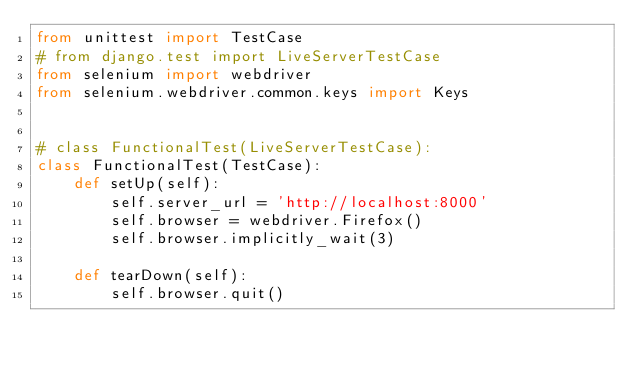Convert code to text. <code><loc_0><loc_0><loc_500><loc_500><_Python_>from unittest import TestCase
# from django.test import LiveServerTestCase
from selenium import webdriver
from selenium.webdriver.common.keys import Keys


# class FunctionalTest(LiveServerTestCase):
class FunctionalTest(TestCase):
    def setUp(self):
        self.server_url = 'http://localhost:8000'
        self.browser = webdriver.Firefox()
        self.browser.implicitly_wait(3)

    def tearDown(self):
        self.browser.quit()

</code> 